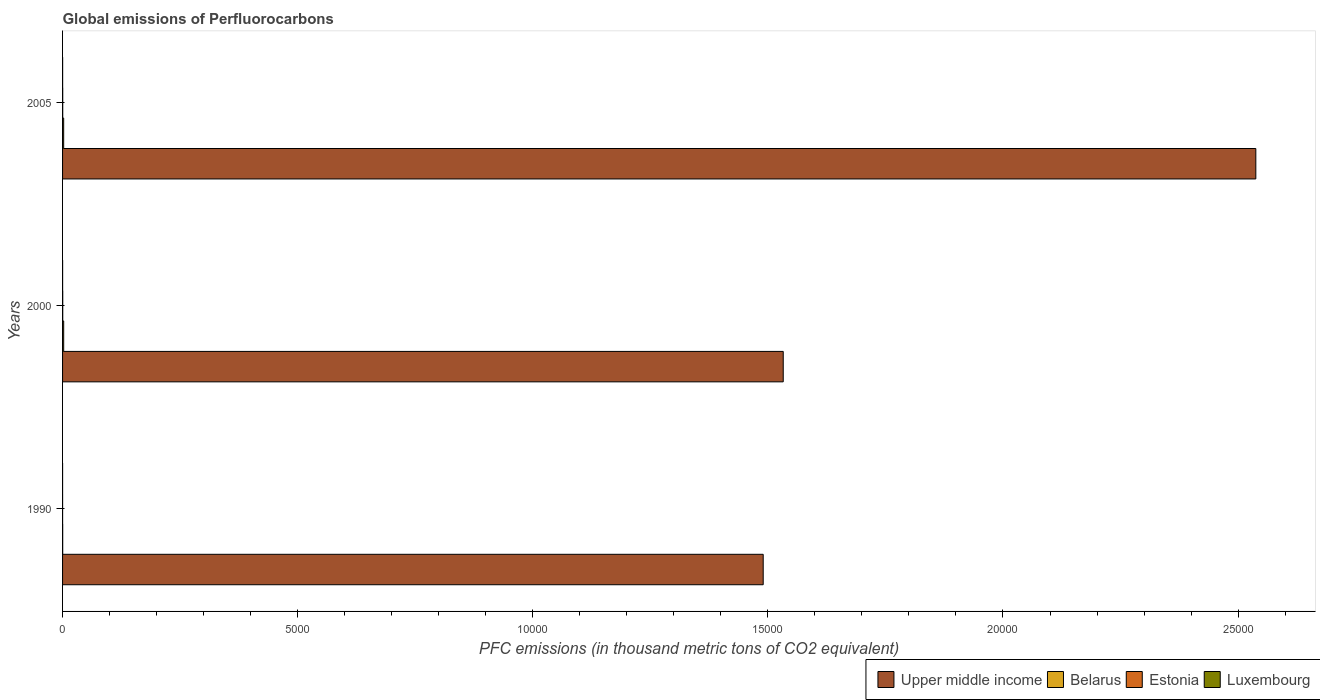How many different coloured bars are there?
Give a very brief answer. 4. Are the number of bars per tick equal to the number of legend labels?
Keep it short and to the point. Yes. What is the global emissions of Perfluorocarbons in Belarus in 1990?
Make the answer very short. 2.6. Across all years, what is the maximum global emissions of Perfluorocarbons in Luxembourg?
Make the answer very short. 1.1. In which year was the global emissions of Perfluorocarbons in Upper middle income maximum?
Give a very brief answer. 2005. What is the total global emissions of Perfluorocarbons in Luxembourg in the graph?
Make the answer very short. 2.2. What is the difference between the global emissions of Perfluorocarbons in Upper middle income in 2000 and that in 2005?
Provide a short and direct response. -1.01e+04. What is the difference between the global emissions of Perfluorocarbons in Luxembourg in 1990 and the global emissions of Perfluorocarbons in Estonia in 2005?
Make the answer very short. -3.3. What is the average global emissions of Perfluorocarbons in Upper middle income per year?
Give a very brief answer. 1.85e+04. In the year 2000, what is the difference between the global emissions of Perfluorocarbons in Estonia and global emissions of Perfluorocarbons in Upper middle income?
Offer a very short reply. -1.53e+04. In how many years, is the global emissions of Perfluorocarbons in Belarus greater than 8000 thousand metric tons?
Offer a very short reply. 0. What is the ratio of the global emissions of Perfluorocarbons in Upper middle income in 1990 to that in 2005?
Offer a very short reply. 0.59. Is the global emissions of Perfluorocarbons in Belarus in 2000 less than that in 2005?
Give a very brief answer. No. What is the difference between the highest and the second highest global emissions of Perfluorocarbons in Luxembourg?
Ensure brevity in your answer.  0.1. What is the difference between the highest and the lowest global emissions of Perfluorocarbons in Luxembourg?
Make the answer very short. 1. Is the sum of the global emissions of Perfluorocarbons in Upper middle income in 1990 and 2000 greater than the maximum global emissions of Perfluorocarbons in Luxembourg across all years?
Provide a succinct answer. Yes. What does the 3rd bar from the top in 2005 represents?
Offer a very short reply. Belarus. What does the 1st bar from the bottom in 2005 represents?
Make the answer very short. Upper middle income. How many bars are there?
Ensure brevity in your answer.  12. How many years are there in the graph?
Ensure brevity in your answer.  3. What is the difference between two consecutive major ticks on the X-axis?
Keep it short and to the point. 5000. Are the values on the major ticks of X-axis written in scientific E-notation?
Your answer should be compact. No. Does the graph contain any zero values?
Offer a terse response. No. Does the graph contain grids?
Make the answer very short. No. How many legend labels are there?
Make the answer very short. 4. What is the title of the graph?
Keep it short and to the point. Global emissions of Perfluorocarbons. Does "El Salvador" appear as one of the legend labels in the graph?
Provide a succinct answer. No. What is the label or title of the X-axis?
Keep it short and to the point. PFC emissions (in thousand metric tons of CO2 equivalent). What is the PFC emissions (in thousand metric tons of CO2 equivalent) in Upper middle income in 1990?
Offer a terse response. 1.49e+04. What is the PFC emissions (in thousand metric tons of CO2 equivalent) in Belarus in 1990?
Offer a terse response. 2.6. What is the PFC emissions (in thousand metric tons of CO2 equivalent) in Estonia in 1990?
Offer a very short reply. 0.5. What is the PFC emissions (in thousand metric tons of CO2 equivalent) in Upper middle income in 2000?
Your answer should be very brief. 1.53e+04. What is the PFC emissions (in thousand metric tons of CO2 equivalent) in Belarus in 2000?
Ensure brevity in your answer.  23.9. What is the PFC emissions (in thousand metric tons of CO2 equivalent) in Upper middle income in 2005?
Give a very brief answer. 2.54e+04. What is the PFC emissions (in thousand metric tons of CO2 equivalent) of Belarus in 2005?
Offer a terse response. 23.4. What is the PFC emissions (in thousand metric tons of CO2 equivalent) in Luxembourg in 2005?
Make the answer very short. 1.1. Across all years, what is the maximum PFC emissions (in thousand metric tons of CO2 equivalent) in Upper middle income?
Offer a terse response. 2.54e+04. Across all years, what is the maximum PFC emissions (in thousand metric tons of CO2 equivalent) of Belarus?
Offer a very short reply. 23.9. Across all years, what is the maximum PFC emissions (in thousand metric tons of CO2 equivalent) in Luxembourg?
Your response must be concise. 1.1. Across all years, what is the minimum PFC emissions (in thousand metric tons of CO2 equivalent) in Upper middle income?
Make the answer very short. 1.49e+04. Across all years, what is the minimum PFC emissions (in thousand metric tons of CO2 equivalent) of Belarus?
Provide a short and direct response. 2.6. What is the total PFC emissions (in thousand metric tons of CO2 equivalent) of Upper middle income in the graph?
Your answer should be compact. 5.56e+04. What is the total PFC emissions (in thousand metric tons of CO2 equivalent) in Belarus in the graph?
Offer a very short reply. 49.9. What is the difference between the PFC emissions (in thousand metric tons of CO2 equivalent) of Upper middle income in 1990 and that in 2000?
Offer a terse response. -426.2. What is the difference between the PFC emissions (in thousand metric tons of CO2 equivalent) in Belarus in 1990 and that in 2000?
Provide a short and direct response. -21.3. What is the difference between the PFC emissions (in thousand metric tons of CO2 equivalent) of Estonia in 1990 and that in 2000?
Your answer should be very brief. -3. What is the difference between the PFC emissions (in thousand metric tons of CO2 equivalent) in Upper middle income in 1990 and that in 2005?
Offer a terse response. -1.05e+04. What is the difference between the PFC emissions (in thousand metric tons of CO2 equivalent) in Belarus in 1990 and that in 2005?
Offer a very short reply. -20.8. What is the difference between the PFC emissions (in thousand metric tons of CO2 equivalent) in Estonia in 1990 and that in 2005?
Make the answer very short. -2.9. What is the difference between the PFC emissions (in thousand metric tons of CO2 equivalent) in Upper middle income in 2000 and that in 2005?
Your answer should be very brief. -1.01e+04. What is the difference between the PFC emissions (in thousand metric tons of CO2 equivalent) in Estonia in 2000 and that in 2005?
Give a very brief answer. 0.1. What is the difference between the PFC emissions (in thousand metric tons of CO2 equivalent) of Upper middle income in 1990 and the PFC emissions (in thousand metric tons of CO2 equivalent) of Belarus in 2000?
Give a very brief answer. 1.49e+04. What is the difference between the PFC emissions (in thousand metric tons of CO2 equivalent) of Upper middle income in 1990 and the PFC emissions (in thousand metric tons of CO2 equivalent) of Estonia in 2000?
Ensure brevity in your answer.  1.49e+04. What is the difference between the PFC emissions (in thousand metric tons of CO2 equivalent) of Upper middle income in 1990 and the PFC emissions (in thousand metric tons of CO2 equivalent) of Luxembourg in 2000?
Offer a terse response. 1.49e+04. What is the difference between the PFC emissions (in thousand metric tons of CO2 equivalent) in Belarus in 1990 and the PFC emissions (in thousand metric tons of CO2 equivalent) in Luxembourg in 2000?
Offer a very short reply. 1.6. What is the difference between the PFC emissions (in thousand metric tons of CO2 equivalent) in Estonia in 1990 and the PFC emissions (in thousand metric tons of CO2 equivalent) in Luxembourg in 2000?
Your answer should be compact. -0.5. What is the difference between the PFC emissions (in thousand metric tons of CO2 equivalent) of Upper middle income in 1990 and the PFC emissions (in thousand metric tons of CO2 equivalent) of Belarus in 2005?
Make the answer very short. 1.49e+04. What is the difference between the PFC emissions (in thousand metric tons of CO2 equivalent) in Upper middle income in 1990 and the PFC emissions (in thousand metric tons of CO2 equivalent) in Estonia in 2005?
Ensure brevity in your answer.  1.49e+04. What is the difference between the PFC emissions (in thousand metric tons of CO2 equivalent) of Upper middle income in 1990 and the PFC emissions (in thousand metric tons of CO2 equivalent) of Luxembourg in 2005?
Provide a short and direct response. 1.49e+04. What is the difference between the PFC emissions (in thousand metric tons of CO2 equivalent) of Belarus in 1990 and the PFC emissions (in thousand metric tons of CO2 equivalent) of Estonia in 2005?
Offer a terse response. -0.8. What is the difference between the PFC emissions (in thousand metric tons of CO2 equivalent) of Belarus in 1990 and the PFC emissions (in thousand metric tons of CO2 equivalent) of Luxembourg in 2005?
Keep it short and to the point. 1.5. What is the difference between the PFC emissions (in thousand metric tons of CO2 equivalent) in Upper middle income in 2000 and the PFC emissions (in thousand metric tons of CO2 equivalent) in Belarus in 2005?
Your answer should be compact. 1.53e+04. What is the difference between the PFC emissions (in thousand metric tons of CO2 equivalent) of Upper middle income in 2000 and the PFC emissions (in thousand metric tons of CO2 equivalent) of Estonia in 2005?
Provide a succinct answer. 1.53e+04. What is the difference between the PFC emissions (in thousand metric tons of CO2 equivalent) in Upper middle income in 2000 and the PFC emissions (in thousand metric tons of CO2 equivalent) in Luxembourg in 2005?
Provide a short and direct response. 1.53e+04. What is the difference between the PFC emissions (in thousand metric tons of CO2 equivalent) in Belarus in 2000 and the PFC emissions (in thousand metric tons of CO2 equivalent) in Estonia in 2005?
Your response must be concise. 20.5. What is the difference between the PFC emissions (in thousand metric tons of CO2 equivalent) in Belarus in 2000 and the PFC emissions (in thousand metric tons of CO2 equivalent) in Luxembourg in 2005?
Your answer should be compact. 22.8. What is the difference between the PFC emissions (in thousand metric tons of CO2 equivalent) of Estonia in 2000 and the PFC emissions (in thousand metric tons of CO2 equivalent) of Luxembourg in 2005?
Your answer should be compact. 2.4. What is the average PFC emissions (in thousand metric tons of CO2 equivalent) in Upper middle income per year?
Ensure brevity in your answer.  1.85e+04. What is the average PFC emissions (in thousand metric tons of CO2 equivalent) of Belarus per year?
Your answer should be compact. 16.63. What is the average PFC emissions (in thousand metric tons of CO2 equivalent) in Estonia per year?
Offer a very short reply. 2.47. What is the average PFC emissions (in thousand metric tons of CO2 equivalent) of Luxembourg per year?
Your answer should be very brief. 0.73. In the year 1990, what is the difference between the PFC emissions (in thousand metric tons of CO2 equivalent) in Upper middle income and PFC emissions (in thousand metric tons of CO2 equivalent) in Belarus?
Keep it short and to the point. 1.49e+04. In the year 1990, what is the difference between the PFC emissions (in thousand metric tons of CO2 equivalent) of Upper middle income and PFC emissions (in thousand metric tons of CO2 equivalent) of Estonia?
Give a very brief answer. 1.49e+04. In the year 1990, what is the difference between the PFC emissions (in thousand metric tons of CO2 equivalent) of Upper middle income and PFC emissions (in thousand metric tons of CO2 equivalent) of Luxembourg?
Give a very brief answer. 1.49e+04. In the year 1990, what is the difference between the PFC emissions (in thousand metric tons of CO2 equivalent) in Belarus and PFC emissions (in thousand metric tons of CO2 equivalent) in Luxembourg?
Your response must be concise. 2.5. In the year 2000, what is the difference between the PFC emissions (in thousand metric tons of CO2 equivalent) of Upper middle income and PFC emissions (in thousand metric tons of CO2 equivalent) of Belarus?
Provide a succinct answer. 1.53e+04. In the year 2000, what is the difference between the PFC emissions (in thousand metric tons of CO2 equivalent) in Upper middle income and PFC emissions (in thousand metric tons of CO2 equivalent) in Estonia?
Keep it short and to the point. 1.53e+04. In the year 2000, what is the difference between the PFC emissions (in thousand metric tons of CO2 equivalent) in Upper middle income and PFC emissions (in thousand metric tons of CO2 equivalent) in Luxembourg?
Your answer should be compact. 1.53e+04. In the year 2000, what is the difference between the PFC emissions (in thousand metric tons of CO2 equivalent) in Belarus and PFC emissions (in thousand metric tons of CO2 equivalent) in Estonia?
Ensure brevity in your answer.  20.4. In the year 2000, what is the difference between the PFC emissions (in thousand metric tons of CO2 equivalent) in Belarus and PFC emissions (in thousand metric tons of CO2 equivalent) in Luxembourg?
Your answer should be very brief. 22.9. In the year 2005, what is the difference between the PFC emissions (in thousand metric tons of CO2 equivalent) of Upper middle income and PFC emissions (in thousand metric tons of CO2 equivalent) of Belarus?
Your answer should be very brief. 2.54e+04. In the year 2005, what is the difference between the PFC emissions (in thousand metric tons of CO2 equivalent) of Upper middle income and PFC emissions (in thousand metric tons of CO2 equivalent) of Estonia?
Give a very brief answer. 2.54e+04. In the year 2005, what is the difference between the PFC emissions (in thousand metric tons of CO2 equivalent) of Upper middle income and PFC emissions (in thousand metric tons of CO2 equivalent) of Luxembourg?
Your answer should be very brief. 2.54e+04. In the year 2005, what is the difference between the PFC emissions (in thousand metric tons of CO2 equivalent) in Belarus and PFC emissions (in thousand metric tons of CO2 equivalent) in Estonia?
Offer a very short reply. 20. In the year 2005, what is the difference between the PFC emissions (in thousand metric tons of CO2 equivalent) of Belarus and PFC emissions (in thousand metric tons of CO2 equivalent) of Luxembourg?
Your response must be concise. 22.3. In the year 2005, what is the difference between the PFC emissions (in thousand metric tons of CO2 equivalent) in Estonia and PFC emissions (in thousand metric tons of CO2 equivalent) in Luxembourg?
Offer a terse response. 2.3. What is the ratio of the PFC emissions (in thousand metric tons of CO2 equivalent) in Upper middle income in 1990 to that in 2000?
Your response must be concise. 0.97. What is the ratio of the PFC emissions (in thousand metric tons of CO2 equivalent) in Belarus in 1990 to that in 2000?
Give a very brief answer. 0.11. What is the ratio of the PFC emissions (in thousand metric tons of CO2 equivalent) in Estonia in 1990 to that in 2000?
Make the answer very short. 0.14. What is the ratio of the PFC emissions (in thousand metric tons of CO2 equivalent) in Upper middle income in 1990 to that in 2005?
Your response must be concise. 0.59. What is the ratio of the PFC emissions (in thousand metric tons of CO2 equivalent) in Belarus in 1990 to that in 2005?
Your answer should be compact. 0.11. What is the ratio of the PFC emissions (in thousand metric tons of CO2 equivalent) of Estonia in 1990 to that in 2005?
Your response must be concise. 0.15. What is the ratio of the PFC emissions (in thousand metric tons of CO2 equivalent) in Luxembourg in 1990 to that in 2005?
Provide a short and direct response. 0.09. What is the ratio of the PFC emissions (in thousand metric tons of CO2 equivalent) in Upper middle income in 2000 to that in 2005?
Offer a terse response. 0.6. What is the ratio of the PFC emissions (in thousand metric tons of CO2 equivalent) in Belarus in 2000 to that in 2005?
Give a very brief answer. 1.02. What is the ratio of the PFC emissions (in thousand metric tons of CO2 equivalent) of Estonia in 2000 to that in 2005?
Provide a succinct answer. 1.03. What is the difference between the highest and the second highest PFC emissions (in thousand metric tons of CO2 equivalent) in Upper middle income?
Ensure brevity in your answer.  1.01e+04. What is the difference between the highest and the second highest PFC emissions (in thousand metric tons of CO2 equivalent) of Estonia?
Make the answer very short. 0.1. What is the difference between the highest and the second highest PFC emissions (in thousand metric tons of CO2 equivalent) of Luxembourg?
Give a very brief answer. 0.1. What is the difference between the highest and the lowest PFC emissions (in thousand metric tons of CO2 equivalent) of Upper middle income?
Offer a very short reply. 1.05e+04. What is the difference between the highest and the lowest PFC emissions (in thousand metric tons of CO2 equivalent) in Belarus?
Your response must be concise. 21.3. 